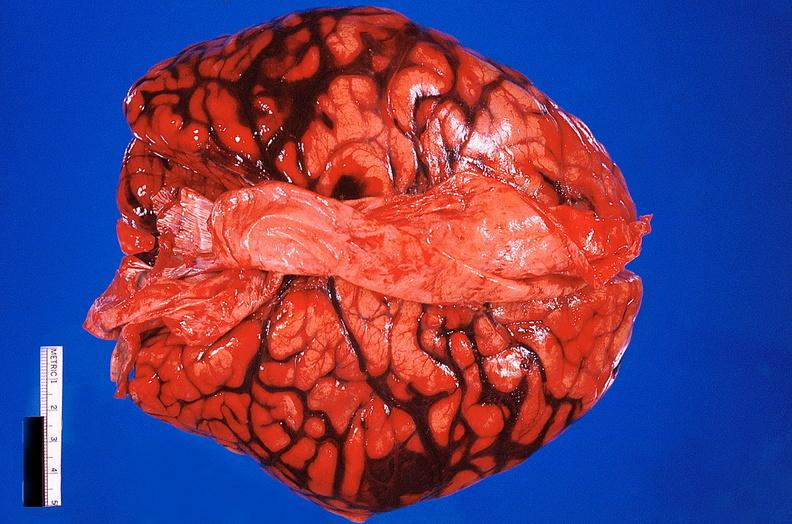does this image show brain, subarachanoid hemorrhage due to ruptured aneurysm?
Answer the question using a single word or phrase. Yes 